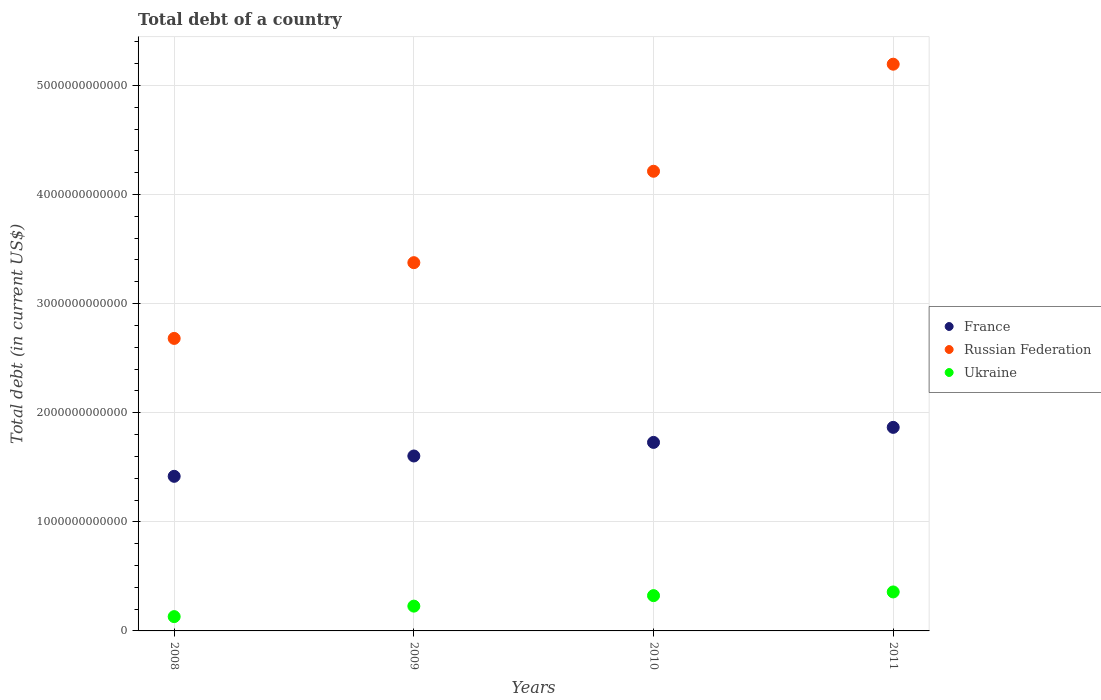How many different coloured dotlines are there?
Make the answer very short. 3. Is the number of dotlines equal to the number of legend labels?
Offer a very short reply. Yes. What is the debt in Ukraine in 2011?
Your answer should be compact. 3.57e+11. Across all years, what is the maximum debt in Ukraine?
Make the answer very short. 3.57e+11. Across all years, what is the minimum debt in Russian Federation?
Give a very brief answer. 2.68e+12. In which year was the debt in Russian Federation maximum?
Offer a terse response. 2011. In which year was the debt in Russian Federation minimum?
Provide a short and direct response. 2008. What is the total debt in Ukraine in the graph?
Provide a succinct answer. 1.04e+12. What is the difference between the debt in Russian Federation in 2008 and that in 2010?
Give a very brief answer. -1.53e+12. What is the difference between the debt in France in 2010 and the debt in Russian Federation in 2009?
Your answer should be very brief. -1.65e+12. What is the average debt in France per year?
Offer a terse response. 1.65e+12. In the year 2008, what is the difference between the debt in France and debt in Russian Federation?
Provide a succinct answer. -1.26e+12. What is the ratio of the debt in France in 2008 to that in 2011?
Your answer should be compact. 0.76. Is the debt in France in 2009 less than that in 2011?
Offer a very short reply. Yes. Is the difference between the debt in France in 2009 and 2010 greater than the difference between the debt in Russian Federation in 2009 and 2010?
Your response must be concise. Yes. What is the difference between the highest and the second highest debt in France?
Provide a short and direct response. 1.38e+11. What is the difference between the highest and the lowest debt in Russian Federation?
Give a very brief answer. 2.51e+12. Is the sum of the debt in Ukraine in 2010 and 2011 greater than the maximum debt in Russian Federation across all years?
Your answer should be very brief. No. Does the debt in Russian Federation monotonically increase over the years?
Your answer should be compact. Yes. Is the debt in Russian Federation strictly greater than the debt in Ukraine over the years?
Offer a very short reply. Yes. How many years are there in the graph?
Provide a short and direct response. 4. What is the difference between two consecutive major ticks on the Y-axis?
Keep it short and to the point. 1.00e+12. Where does the legend appear in the graph?
Provide a short and direct response. Center right. What is the title of the graph?
Offer a terse response. Total debt of a country. Does "South Asia" appear as one of the legend labels in the graph?
Ensure brevity in your answer.  No. What is the label or title of the Y-axis?
Offer a terse response. Total debt (in current US$). What is the Total debt (in current US$) in France in 2008?
Provide a short and direct response. 1.42e+12. What is the Total debt (in current US$) in Russian Federation in 2008?
Make the answer very short. 2.68e+12. What is the Total debt (in current US$) in Ukraine in 2008?
Provide a short and direct response. 1.31e+11. What is the Total debt (in current US$) of France in 2009?
Your answer should be very brief. 1.60e+12. What is the Total debt (in current US$) in Russian Federation in 2009?
Offer a very short reply. 3.38e+12. What is the Total debt (in current US$) in Ukraine in 2009?
Keep it short and to the point. 2.27e+11. What is the Total debt (in current US$) in France in 2010?
Offer a terse response. 1.73e+12. What is the Total debt (in current US$) of Russian Federation in 2010?
Provide a short and direct response. 4.21e+12. What is the Total debt (in current US$) in Ukraine in 2010?
Provide a short and direct response. 3.23e+11. What is the Total debt (in current US$) of France in 2011?
Provide a short and direct response. 1.87e+12. What is the Total debt (in current US$) in Russian Federation in 2011?
Keep it short and to the point. 5.19e+12. What is the Total debt (in current US$) in Ukraine in 2011?
Your response must be concise. 3.57e+11. Across all years, what is the maximum Total debt (in current US$) in France?
Offer a terse response. 1.87e+12. Across all years, what is the maximum Total debt (in current US$) of Russian Federation?
Make the answer very short. 5.19e+12. Across all years, what is the maximum Total debt (in current US$) in Ukraine?
Your answer should be very brief. 3.57e+11. Across all years, what is the minimum Total debt (in current US$) of France?
Your answer should be compact. 1.42e+12. Across all years, what is the minimum Total debt (in current US$) of Russian Federation?
Keep it short and to the point. 2.68e+12. Across all years, what is the minimum Total debt (in current US$) in Ukraine?
Provide a succinct answer. 1.31e+11. What is the total Total debt (in current US$) in France in the graph?
Offer a very short reply. 6.61e+12. What is the total Total debt (in current US$) of Russian Federation in the graph?
Give a very brief answer. 1.55e+13. What is the total Total debt (in current US$) of Ukraine in the graph?
Ensure brevity in your answer.  1.04e+12. What is the difference between the Total debt (in current US$) in France in 2008 and that in 2009?
Your answer should be very brief. -1.86e+11. What is the difference between the Total debt (in current US$) of Russian Federation in 2008 and that in 2009?
Give a very brief answer. -6.94e+11. What is the difference between the Total debt (in current US$) of Ukraine in 2008 and that in 2009?
Your answer should be very brief. -9.61e+1. What is the difference between the Total debt (in current US$) of France in 2008 and that in 2010?
Offer a terse response. -3.11e+11. What is the difference between the Total debt (in current US$) of Russian Federation in 2008 and that in 2010?
Ensure brevity in your answer.  -1.53e+12. What is the difference between the Total debt (in current US$) of Ukraine in 2008 and that in 2010?
Offer a terse response. -1.92e+11. What is the difference between the Total debt (in current US$) of France in 2008 and that in 2011?
Provide a succinct answer. -4.49e+11. What is the difference between the Total debt (in current US$) of Russian Federation in 2008 and that in 2011?
Provide a succinct answer. -2.51e+12. What is the difference between the Total debt (in current US$) of Ukraine in 2008 and that in 2011?
Offer a terse response. -2.26e+11. What is the difference between the Total debt (in current US$) of France in 2009 and that in 2010?
Provide a succinct answer. -1.25e+11. What is the difference between the Total debt (in current US$) in Russian Federation in 2009 and that in 2010?
Make the answer very short. -8.38e+11. What is the difference between the Total debt (in current US$) of Ukraine in 2009 and that in 2010?
Offer a terse response. -9.63e+1. What is the difference between the Total debt (in current US$) of France in 2009 and that in 2011?
Your answer should be very brief. -2.62e+11. What is the difference between the Total debt (in current US$) in Russian Federation in 2009 and that in 2011?
Your response must be concise. -1.82e+12. What is the difference between the Total debt (in current US$) of Ukraine in 2009 and that in 2011?
Your response must be concise. -1.30e+11. What is the difference between the Total debt (in current US$) of France in 2010 and that in 2011?
Ensure brevity in your answer.  -1.38e+11. What is the difference between the Total debt (in current US$) in Russian Federation in 2010 and that in 2011?
Provide a succinct answer. -9.81e+11. What is the difference between the Total debt (in current US$) of Ukraine in 2010 and that in 2011?
Your answer should be very brief. -3.38e+1. What is the difference between the Total debt (in current US$) in France in 2008 and the Total debt (in current US$) in Russian Federation in 2009?
Give a very brief answer. -1.96e+12. What is the difference between the Total debt (in current US$) of France in 2008 and the Total debt (in current US$) of Ukraine in 2009?
Your answer should be compact. 1.19e+12. What is the difference between the Total debt (in current US$) of Russian Federation in 2008 and the Total debt (in current US$) of Ukraine in 2009?
Provide a short and direct response. 2.45e+12. What is the difference between the Total debt (in current US$) of France in 2008 and the Total debt (in current US$) of Russian Federation in 2010?
Ensure brevity in your answer.  -2.80e+12. What is the difference between the Total debt (in current US$) of France in 2008 and the Total debt (in current US$) of Ukraine in 2010?
Ensure brevity in your answer.  1.09e+12. What is the difference between the Total debt (in current US$) of Russian Federation in 2008 and the Total debt (in current US$) of Ukraine in 2010?
Your response must be concise. 2.36e+12. What is the difference between the Total debt (in current US$) of France in 2008 and the Total debt (in current US$) of Russian Federation in 2011?
Your response must be concise. -3.78e+12. What is the difference between the Total debt (in current US$) of France in 2008 and the Total debt (in current US$) of Ukraine in 2011?
Keep it short and to the point. 1.06e+12. What is the difference between the Total debt (in current US$) of Russian Federation in 2008 and the Total debt (in current US$) of Ukraine in 2011?
Offer a terse response. 2.32e+12. What is the difference between the Total debt (in current US$) of France in 2009 and the Total debt (in current US$) of Russian Federation in 2010?
Give a very brief answer. -2.61e+12. What is the difference between the Total debt (in current US$) of France in 2009 and the Total debt (in current US$) of Ukraine in 2010?
Keep it short and to the point. 1.28e+12. What is the difference between the Total debt (in current US$) in Russian Federation in 2009 and the Total debt (in current US$) in Ukraine in 2010?
Give a very brief answer. 3.05e+12. What is the difference between the Total debt (in current US$) in France in 2009 and the Total debt (in current US$) in Russian Federation in 2011?
Give a very brief answer. -3.59e+12. What is the difference between the Total debt (in current US$) of France in 2009 and the Total debt (in current US$) of Ukraine in 2011?
Offer a very short reply. 1.25e+12. What is the difference between the Total debt (in current US$) of Russian Federation in 2009 and the Total debt (in current US$) of Ukraine in 2011?
Your response must be concise. 3.02e+12. What is the difference between the Total debt (in current US$) of France in 2010 and the Total debt (in current US$) of Russian Federation in 2011?
Offer a very short reply. -3.47e+12. What is the difference between the Total debt (in current US$) in France in 2010 and the Total debt (in current US$) in Ukraine in 2011?
Provide a short and direct response. 1.37e+12. What is the difference between the Total debt (in current US$) of Russian Federation in 2010 and the Total debt (in current US$) of Ukraine in 2011?
Offer a very short reply. 3.86e+12. What is the average Total debt (in current US$) of France per year?
Ensure brevity in your answer.  1.65e+12. What is the average Total debt (in current US$) of Russian Federation per year?
Make the answer very short. 3.87e+12. What is the average Total debt (in current US$) of Ukraine per year?
Provide a succinct answer. 2.60e+11. In the year 2008, what is the difference between the Total debt (in current US$) of France and Total debt (in current US$) of Russian Federation?
Offer a very short reply. -1.26e+12. In the year 2008, what is the difference between the Total debt (in current US$) of France and Total debt (in current US$) of Ukraine?
Offer a terse response. 1.29e+12. In the year 2008, what is the difference between the Total debt (in current US$) in Russian Federation and Total debt (in current US$) in Ukraine?
Provide a succinct answer. 2.55e+12. In the year 2009, what is the difference between the Total debt (in current US$) of France and Total debt (in current US$) of Russian Federation?
Offer a very short reply. -1.77e+12. In the year 2009, what is the difference between the Total debt (in current US$) of France and Total debt (in current US$) of Ukraine?
Keep it short and to the point. 1.38e+12. In the year 2009, what is the difference between the Total debt (in current US$) in Russian Federation and Total debt (in current US$) in Ukraine?
Your answer should be very brief. 3.15e+12. In the year 2010, what is the difference between the Total debt (in current US$) in France and Total debt (in current US$) in Russian Federation?
Offer a terse response. -2.49e+12. In the year 2010, what is the difference between the Total debt (in current US$) in France and Total debt (in current US$) in Ukraine?
Your response must be concise. 1.40e+12. In the year 2010, what is the difference between the Total debt (in current US$) of Russian Federation and Total debt (in current US$) of Ukraine?
Provide a short and direct response. 3.89e+12. In the year 2011, what is the difference between the Total debt (in current US$) of France and Total debt (in current US$) of Russian Federation?
Provide a succinct answer. -3.33e+12. In the year 2011, what is the difference between the Total debt (in current US$) in France and Total debt (in current US$) in Ukraine?
Your response must be concise. 1.51e+12. In the year 2011, what is the difference between the Total debt (in current US$) of Russian Federation and Total debt (in current US$) of Ukraine?
Offer a very short reply. 4.84e+12. What is the ratio of the Total debt (in current US$) in France in 2008 to that in 2009?
Provide a succinct answer. 0.88. What is the ratio of the Total debt (in current US$) of Russian Federation in 2008 to that in 2009?
Provide a short and direct response. 0.79. What is the ratio of the Total debt (in current US$) of Ukraine in 2008 to that in 2009?
Keep it short and to the point. 0.58. What is the ratio of the Total debt (in current US$) in France in 2008 to that in 2010?
Your response must be concise. 0.82. What is the ratio of the Total debt (in current US$) in Russian Federation in 2008 to that in 2010?
Keep it short and to the point. 0.64. What is the ratio of the Total debt (in current US$) in Ukraine in 2008 to that in 2010?
Offer a terse response. 0.41. What is the ratio of the Total debt (in current US$) in France in 2008 to that in 2011?
Offer a very short reply. 0.76. What is the ratio of the Total debt (in current US$) in Russian Federation in 2008 to that in 2011?
Your response must be concise. 0.52. What is the ratio of the Total debt (in current US$) in Ukraine in 2008 to that in 2011?
Make the answer very short. 0.37. What is the ratio of the Total debt (in current US$) in France in 2009 to that in 2010?
Ensure brevity in your answer.  0.93. What is the ratio of the Total debt (in current US$) of Russian Federation in 2009 to that in 2010?
Provide a succinct answer. 0.8. What is the ratio of the Total debt (in current US$) in Ukraine in 2009 to that in 2010?
Keep it short and to the point. 0.7. What is the ratio of the Total debt (in current US$) in France in 2009 to that in 2011?
Provide a short and direct response. 0.86. What is the ratio of the Total debt (in current US$) in Russian Federation in 2009 to that in 2011?
Your answer should be compact. 0.65. What is the ratio of the Total debt (in current US$) of Ukraine in 2009 to that in 2011?
Your answer should be compact. 0.64. What is the ratio of the Total debt (in current US$) of France in 2010 to that in 2011?
Offer a terse response. 0.93. What is the ratio of the Total debt (in current US$) in Russian Federation in 2010 to that in 2011?
Your answer should be very brief. 0.81. What is the ratio of the Total debt (in current US$) in Ukraine in 2010 to that in 2011?
Ensure brevity in your answer.  0.91. What is the difference between the highest and the second highest Total debt (in current US$) in France?
Ensure brevity in your answer.  1.38e+11. What is the difference between the highest and the second highest Total debt (in current US$) of Russian Federation?
Give a very brief answer. 9.81e+11. What is the difference between the highest and the second highest Total debt (in current US$) in Ukraine?
Your response must be concise. 3.38e+1. What is the difference between the highest and the lowest Total debt (in current US$) in France?
Provide a succinct answer. 4.49e+11. What is the difference between the highest and the lowest Total debt (in current US$) in Russian Federation?
Your response must be concise. 2.51e+12. What is the difference between the highest and the lowest Total debt (in current US$) of Ukraine?
Keep it short and to the point. 2.26e+11. 